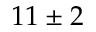<formula> <loc_0><loc_0><loc_500><loc_500>1 1 \pm 2</formula> 